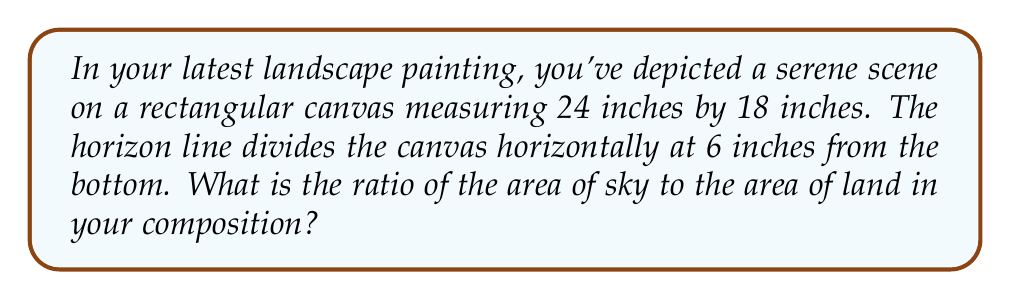Teach me how to tackle this problem. Let's approach this step-by-step:

1) First, we need to calculate the total area of the canvas:
   $$A_{total} = 24 \text{ inches} \times 18 \text{ inches} = 432 \text{ square inches}$$

2) Now, let's calculate the area of the land portion:
   $$A_{land} = 24 \text{ inches} \times 6 \text{ inches} = 144 \text{ square inches}$$

3) The area of the sky is the difference between the total area and the land area:
   $$A_{sky} = A_{total} - A_{land} = 432 - 144 = 288 \text{ square inches}$$

4) To find the ratio of sky to land, we divide the area of sky by the area of land:
   $$\text{Ratio} = \frac{A_{sky}}{A_{land}} = \frac{288}{144} = 2$$

5) This can be simplified to:
   $$\text{Sky : Land} = 2 : 1$$

[asy]
size(200);
draw((0,0)--(120,0)--(120,90)--(0,90)--cycle);
draw((0,30)--(120,30),dashed);
label("24 inches", (60,0), S);
label("18 inches", (120,45), E);
label("6 inches", (120,15), E);
label("Sky", (60,60));
label("Land", (60,15));
[/asy]
Answer: 2:1 